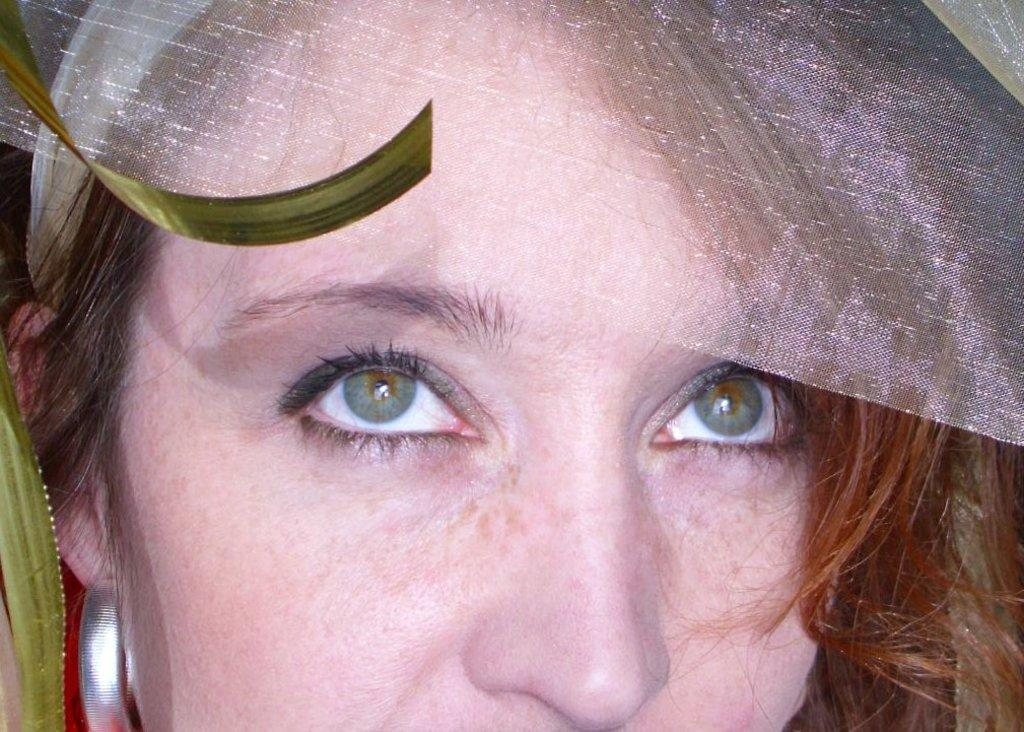What is the main subject of the image? There is a woman's face in the image. What can be seen on the woman's head? The woman has a white cloth on her head. What color and type of objects are on the left side of the image? There are green color things on the left side of the image. What direction is the current flowing in the image? There is no reference to a current or water in the image, so it's not possible to determine the direction of any current. 